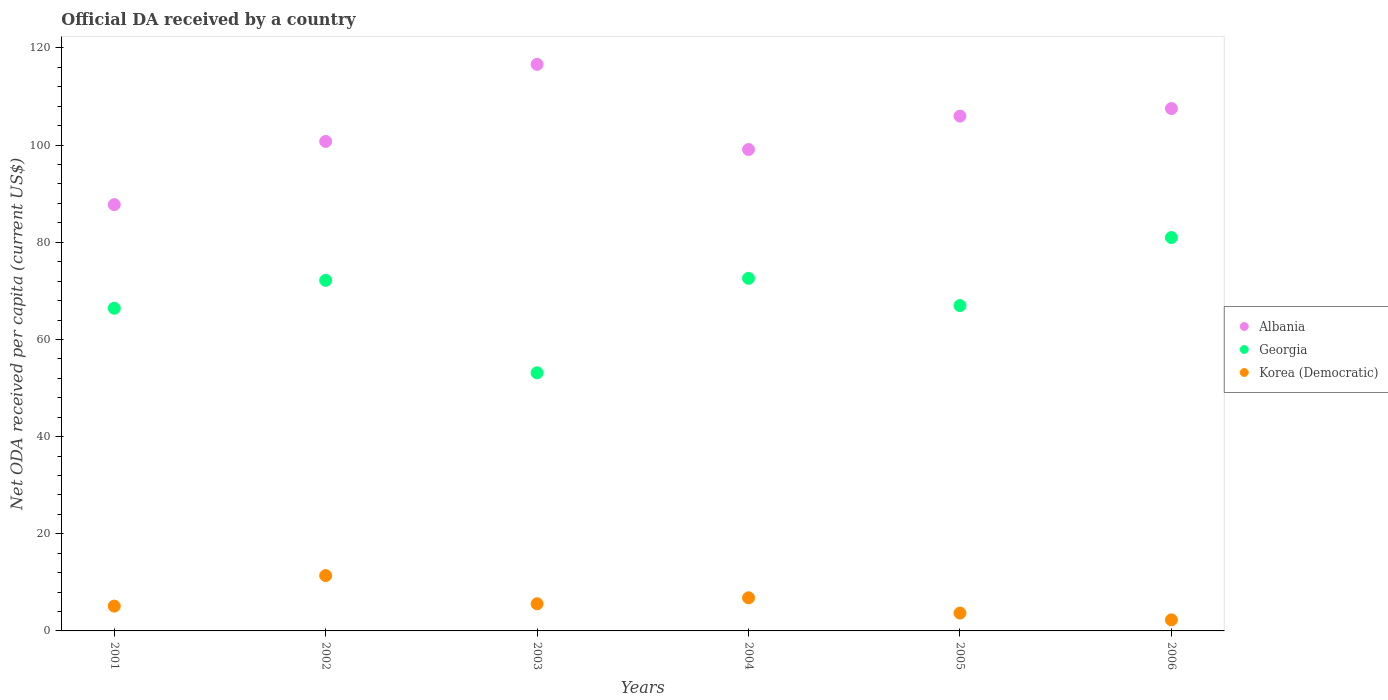What is the ODA received in in Georgia in 2005?
Offer a terse response. 66.97. Across all years, what is the maximum ODA received in in Georgia?
Your response must be concise. 80.98. Across all years, what is the minimum ODA received in in Korea (Democratic)?
Give a very brief answer. 2.28. In which year was the ODA received in in Albania maximum?
Keep it short and to the point. 2003. In which year was the ODA received in in Albania minimum?
Give a very brief answer. 2001. What is the total ODA received in in Korea (Democratic) in the graph?
Offer a very short reply. 34.85. What is the difference between the ODA received in in Albania in 2002 and that in 2005?
Offer a terse response. -5.21. What is the difference between the ODA received in in Georgia in 2002 and the ODA received in in Korea (Democratic) in 2003?
Ensure brevity in your answer.  66.58. What is the average ODA received in in Korea (Democratic) per year?
Provide a short and direct response. 5.81. In the year 2005, what is the difference between the ODA received in in Korea (Democratic) and ODA received in in Georgia?
Make the answer very short. -63.29. In how many years, is the ODA received in in Georgia greater than 68 US$?
Offer a very short reply. 3. What is the ratio of the ODA received in in Albania in 2002 to that in 2006?
Your response must be concise. 0.94. Is the difference between the ODA received in in Korea (Democratic) in 2004 and 2005 greater than the difference between the ODA received in in Georgia in 2004 and 2005?
Provide a succinct answer. No. What is the difference between the highest and the second highest ODA received in in Korea (Democratic)?
Provide a short and direct response. 4.57. What is the difference between the highest and the lowest ODA received in in Albania?
Your answer should be very brief. 28.88. In how many years, is the ODA received in in Georgia greater than the average ODA received in in Georgia taken over all years?
Provide a succinct answer. 3. Is the sum of the ODA received in in Georgia in 2003 and 2004 greater than the maximum ODA received in in Albania across all years?
Keep it short and to the point. Yes. Is it the case that in every year, the sum of the ODA received in in Georgia and ODA received in in Albania  is greater than the ODA received in in Korea (Democratic)?
Make the answer very short. Yes. Is the ODA received in in Korea (Democratic) strictly greater than the ODA received in in Albania over the years?
Your response must be concise. No. Is the ODA received in in Korea (Democratic) strictly less than the ODA received in in Georgia over the years?
Provide a short and direct response. Yes. How many dotlines are there?
Give a very brief answer. 3. What is the difference between two consecutive major ticks on the Y-axis?
Make the answer very short. 20. Are the values on the major ticks of Y-axis written in scientific E-notation?
Give a very brief answer. No. How many legend labels are there?
Ensure brevity in your answer.  3. What is the title of the graph?
Provide a succinct answer. Official DA received by a country. Does "Virgin Islands" appear as one of the legend labels in the graph?
Offer a terse response. No. What is the label or title of the Y-axis?
Offer a terse response. Net ODA received per capita (current US$). What is the Net ODA received per capita (current US$) of Albania in 2001?
Your answer should be very brief. 87.75. What is the Net ODA received per capita (current US$) in Georgia in 2001?
Ensure brevity in your answer.  66.42. What is the Net ODA received per capita (current US$) of Korea (Democratic) in 2001?
Offer a terse response. 5.11. What is the Net ODA received per capita (current US$) in Albania in 2002?
Provide a succinct answer. 100.76. What is the Net ODA received per capita (current US$) in Georgia in 2002?
Make the answer very short. 72.17. What is the Net ODA received per capita (current US$) of Korea (Democratic) in 2002?
Keep it short and to the point. 11.39. What is the Net ODA received per capita (current US$) in Albania in 2003?
Your answer should be very brief. 116.63. What is the Net ODA received per capita (current US$) in Georgia in 2003?
Give a very brief answer. 53.13. What is the Net ODA received per capita (current US$) in Korea (Democratic) in 2003?
Provide a succinct answer. 5.59. What is the Net ODA received per capita (current US$) in Albania in 2004?
Your response must be concise. 99.09. What is the Net ODA received per capita (current US$) in Georgia in 2004?
Make the answer very short. 72.58. What is the Net ODA received per capita (current US$) in Korea (Democratic) in 2004?
Offer a very short reply. 6.82. What is the Net ODA received per capita (current US$) in Albania in 2005?
Give a very brief answer. 105.97. What is the Net ODA received per capita (current US$) in Georgia in 2005?
Give a very brief answer. 66.97. What is the Net ODA received per capita (current US$) in Korea (Democratic) in 2005?
Give a very brief answer. 3.68. What is the Net ODA received per capita (current US$) in Albania in 2006?
Your answer should be compact. 107.53. What is the Net ODA received per capita (current US$) in Georgia in 2006?
Your response must be concise. 80.98. What is the Net ODA received per capita (current US$) in Korea (Democratic) in 2006?
Keep it short and to the point. 2.28. Across all years, what is the maximum Net ODA received per capita (current US$) in Albania?
Give a very brief answer. 116.63. Across all years, what is the maximum Net ODA received per capita (current US$) in Georgia?
Your answer should be very brief. 80.98. Across all years, what is the maximum Net ODA received per capita (current US$) in Korea (Democratic)?
Your answer should be compact. 11.39. Across all years, what is the minimum Net ODA received per capita (current US$) in Albania?
Your response must be concise. 87.75. Across all years, what is the minimum Net ODA received per capita (current US$) of Georgia?
Offer a terse response. 53.13. Across all years, what is the minimum Net ODA received per capita (current US$) in Korea (Democratic)?
Keep it short and to the point. 2.28. What is the total Net ODA received per capita (current US$) in Albania in the graph?
Provide a short and direct response. 617.73. What is the total Net ODA received per capita (current US$) of Georgia in the graph?
Provide a short and direct response. 412.25. What is the total Net ODA received per capita (current US$) of Korea (Democratic) in the graph?
Your answer should be very brief. 34.85. What is the difference between the Net ODA received per capita (current US$) in Albania in 2001 and that in 2002?
Your answer should be very brief. -13.01. What is the difference between the Net ODA received per capita (current US$) in Georgia in 2001 and that in 2002?
Your answer should be very brief. -5.75. What is the difference between the Net ODA received per capita (current US$) in Korea (Democratic) in 2001 and that in 2002?
Your response must be concise. -6.28. What is the difference between the Net ODA received per capita (current US$) in Albania in 2001 and that in 2003?
Provide a succinct answer. -28.88. What is the difference between the Net ODA received per capita (current US$) of Georgia in 2001 and that in 2003?
Offer a very short reply. 13.29. What is the difference between the Net ODA received per capita (current US$) in Korea (Democratic) in 2001 and that in 2003?
Provide a short and direct response. -0.48. What is the difference between the Net ODA received per capita (current US$) of Albania in 2001 and that in 2004?
Keep it short and to the point. -11.34. What is the difference between the Net ODA received per capita (current US$) in Georgia in 2001 and that in 2004?
Make the answer very short. -6.16. What is the difference between the Net ODA received per capita (current US$) of Korea (Democratic) in 2001 and that in 2004?
Offer a very short reply. -1.71. What is the difference between the Net ODA received per capita (current US$) of Albania in 2001 and that in 2005?
Offer a very short reply. -18.22. What is the difference between the Net ODA received per capita (current US$) in Georgia in 2001 and that in 2005?
Keep it short and to the point. -0.55. What is the difference between the Net ODA received per capita (current US$) of Korea (Democratic) in 2001 and that in 2005?
Your response must be concise. 1.43. What is the difference between the Net ODA received per capita (current US$) of Albania in 2001 and that in 2006?
Provide a short and direct response. -19.78. What is the difference between the Net ODA received per capita (current US$) in Georgia in 2001 and that in 2006?
Keep it short and to the point. -14.56. What is the difference between the Net ODA received per capita (current US$) in Korea (Democratic) in 2001 and that in 2006?
Make the answer very short. 2.83. What is the difference between the Net ODA received per capita (current US$) of Albania in 2002 and that in 2003?
Offer a very short reply. -15.87. What is the difference between the Net ODA received per capita (current US$) of Georgia in 2002 and that in 2003?
Ensure brevity in your answer.  19.04. What is the difference between the Net ODA received per capita (current US$) in Korea (Democratic) in 2002 and that in 2003?
Keep it short and to the point. 5.8. What is the difference between the Net ODA received per capita (current US$) in Albania in 2002 and that in 2004?
Provide a succinct answer. 1.67. What is the difference between the Net ODA received per capita (current US$) of Georgia in 2002 and that in 2004?
Provide a succinct answer. -0.41. What is the difference between the Net ODA received per capita (current US$) of Korea (Democratic) in 2002 and that in 2004?
Provide a succinct answer. 4.57. What is the difference between the Net ODA received per capita (current US$) of Albania in 2002 and that in 2005?
Provide a succinct answer. -5.21. What is the difference between the Net ODA received per capita (current US$) of Georgia in 2002 and that in 2005?
Keep it short and to the point. 5.2. What is the difference between the Net ODA received per capita (current US$) in Korea (Democratic) in 2002 and that in 2005?
Provide a short and direct response. 7.71. What is the difference between the Net ODA received per capita (current US$) of Albania in 2002 and that in 2006?
Provide a short and direct response. -6.77. What is the difference between the Net ODA received per capita (current US$) in Georgia in 2002 and that in 2006?
Your answer should be compact. -8.81. What is the difference between the Net ODA received per capita (current US$) of Korea (Democratic) in 2002 and that in 2006?
Provide a short and direct response. 9.11. What is the difference between the Net ODA received per capita (current US$) of Albania in 2003 and that in 2004?
Offer a terse response. 17.53. What is the difference between the Net ODA received per capita (current US$) in Georgia in 2003 and that in 2004?
Provide a short and direct response. -19.45. What is the difference between the Net ODA received per capita (current US$) of Korea (Democratic) in 2003 and that in 2004?
Your response must be concise. -1.23. What is the difference between the Net ODA received per capita (current US$) of Albania in 2003 and that in 2005?
Ensure brevity in your answer.  10.65. What is the difference between the Net ODA received per capita (current US$) of Georgia in 2003 and that in 2005?
Keep it short and to the point. -13.84. What is the difference between the Net ODA received per capita (current US$) of Korea (Democratic) in 2003 and that in 2005?
Keep it short and to the point. 1.91. What is the difference between the Net ODA received per capita (current US$) in Albania in 2003 and that in 2006?
Ensure brevity in your answer.  9.1. What is the difference between the Net ODA received per capita (current US$) in Georgia in 2003 and that in 2006?
Ensure brevity in your answer.  -27.84. What is the difference between the Net ODA received per capita (current US$) in Korea (Democratic) in 2003 and that in 2006?
Offer a very short reply. 3.31. What is the difference between the Net ODA received per capita (current US$) of Albania in 2004 and that in 2005?
Ensure brevity in your answer.  -6.88. What is the difference between the Net ODA received per capita (current US$) of Georgia in 2004 and that in 2005?
Offer a terse response. 5.61. What is the difference between the Net ODA received per capita (current US$) in Korea (Democratic) in 2004 and that in 2005?
Provide a short and direct response. 3.14. What is the difference between the Net ODA received per capita (current US$) in Albania in 2004 and that in 2006?
Your response must be concise. -8.43. What is the difference between the Net ODA received per capita (current US$) of Georgia in 2004 and that in 2006?
Your answer should be very brief. -8.4. What is the difference between the Net ODA received per capita (current US$) of Korea (Democratic) in 2004 and that in 2006?
Ensure brevity in your answer.  4.54. What is the difference between the Net ODA received per capita (current US$) of Albania in 2005 and that in 2006?
Offer a terse response. -1.55. What is the difference between the Net ODA received per capita (current US$) in Georgia in 2005 and that in 2006?
Provide a short and direct response. -14.01. What is the difference between the Net ODA received per capita (current US$) in Korea (Democratic) in 2005 and that in 2006?
Offer a terse response. 1.4. What is the difference between the Net ODA received per capita (current US$) in Albania in 2001 and the Net ODA received per capita (current US$) in Georgia in 2002?
Make the answer very short. 15.58. What is the difference between the Net ODA received per capita (current US$) of Albania in 2001 and the Net ODA received per capita (current US$) of Korea (Democratic) in 2002?
Provide a short and direct response. 76.36. What is the difference between the Net ODA received per capita (current US$) in Georgia in 2001 and the Net ODA received per capita (current US$) in Korea (Democratic) in 2002?
Your answer should be compact. 55.03. What is the difference between the Net ODA received per capita (current US$) in Albania in 2001 and the Net ODA received per capita (current US$) in Georgia in 2003?
Your answer should be compact. 34.62. What is the difference between the Net ODA received per capita (current US$) of Albania in 2001 and the Net ODA received per capita (current US$) of Korea (Democratic) in 2003?
Your answer should be very brief. 82.16. What is the difference between the Net ODA received per capita (current US$) of Georgia in 2001 and the Net ODA received per capita (current US$) of Korea (Democratic) in 2003?
Offer a very short reply. 60.84. What is the difference between the Net ODA received per capita (current US$) of Albania in 2001 and the Net ODA received per capita (current US$) of Georgia in 2004?
Make the answer very short. 15.17. What is the difference between the Net ODA received per capita (current US$) in Albania in 2001 and the Net ODA received per capita (current US$) in Korea (Democratic) in 2004?
Keep it short and to the point. 80.93. What is the difference between the Net ODA received per capita (current US$) of Georgia in 2001 and the Net ODA received per capita (current US$) of Korea (Democratic) in 2004?
Provide a succinct answer. 59.6. What is the difference between the Net ODA received per capita (current US$) in Albania in 2001 and the Net ODA received per capita (current US$) in Georgia in 2005?
Offer a very short reply. 20.78. What is the difference between the Net ODA received per capita (current US$) in Albania in 2001 and the Net ODA received per capita (current US$) in Korea (Democratic) in 2005?
Ensure brevity in your answer.  84.07. What is the difference between the Net ODA received per capita (current US$) in Georgia in 2001 and the Net ODA received per capita (current US$) in Korea (Democratic) in 2005?
Provide a succinct answer. 62.74. What is the difference between the Net ODA received per capita (current US$) in Albania in 2001 and the Net ODA received per capita (current US$) in Georgia in 2006?
Keep it short and to the point. 6.77. What is the difference between the Net ODA received per capita (current US$) in Albania in 2001 and the Net ODA received per capita (current US$) in Korea (Democratic) in 2006?
Your answer should be very brief. 85.47. What is the difference between the Net ODA received per capita (current US$) of Georgia in 2001 and the Net ODA received per capita (current US$) of Korea (Democratic) in 2006?
Give a very brief answer. 64.14. What is the difference between the Net ODA received per capita (current US$) in Albania in 2002 and the Net ODA received per capita (current US$) in Georgia in 2003?
Your answer should be compact. 47.63. What is the difference between the Net ODA received per capita (current US$) in Albania in 2002 and the Net ODA received per capita (current US$) in Korea (Democratic) in 2003?
Your response must be concise. 95.17. What is the difference between the Net ODA received per capita (current US$) in Georgia in 2002 and the Net ODA received per capita (current US$) in Korea (Democratic) in 2003?
Offer a very short reply. 66.58. What is the difference between the Net ODA received per capita (current US$) of Albania in 2002 and the Net ODA received per capita (current US$) of Georgia in 2004?
Make the answer very short. 28.18. What is the difference between the Net ODA received per capita (current US$) in Albania in 2002 and the Net ODA received per capita (current US$) in Korea (Democratic) in 2004?
Provide a succinct answer. 93.94. What is the difference between the Net ODA received per capita (current US$) of Georgia in 2002 and the Net ODA received per capita (current US$) of Korea (Democratic) in 2004?
Keep it short and to the point. 65.35. What is the difference between the Net ODA received per capita (current US$) in Albania in 2002 and the Net ODA received per capita (current US$) in Georgia in 2005?
Your answer should be compact. 33.79. What is the difference between the Net ODA received per capita (current US$) in Albania in 2002 and the Net ODA received per capita (current US$) in Korea (Democratic) in 2005?
Your response must be concise. 97.08. What is the difference between the Net ODA received per capita (current US$) of Georgia in 2002 and the Net ODA received per capita (current US$) of Korea (Democratic) in 2005?
Offer a terse response. 68.49. What is the difference between the Net ODA received per capita (current US$) of Albania in 2002 and the Net ODA received per capita (current US$) of Georgia in 2006?
Provide a succinct answer. 19.78. What is the difference between the Net ODA received per capita (current US$) in Albania in 2002 and the Net ODA received per capita (current US$) in Korea (Democratic) in 2006?
Provide a short and direct response. 98.48. What is the difference between the Net ODA received per capita (current US$) in Georgia in 2002 and the Net ODA received per capita (current US$) in Korea (Democratic) in 2006?
Make the answer very short. 69.89. What is the difference between the Net ODA received per capita (current US$) of Albania in 2003 and the Net ODA received per capita (current US$) of Georgia in 2004?
Provide a short and direct response. 44.05. What is the difference between the Net ODA received per capita (current US$) of Albania in 2003 and the Net ODA received per capita (current US$) of Korea (Democratic) in 2004?
Your answer should be very brief. 109.81. What is the difference between the Net ODA received per capita (current US$) in Georgia in 2003 and the Net ODA received per capita (current US$) in Korea (Democratic) in 2004?
Provide a short and direct response. 46.32. What is the difference between the Net ODA received per capita (current US$) in Albania in 2003 and the Net ODA received per capita (current US$) in Georgia in 2005?
Provide a short and direct response. 49.66. What is the difference between the Net ODA received per capita (current US$) in Albania in 2003 and the Net ODA received per capita (current US$) in Korea (Democratic) in 2005?
Give a very brief answer. 112.95. What is the difference between the Net ODA received per capita (current US$) in Georgia in 2003 and the Net ODA received per capita (current US$) in Korea (Democratic) in 2005?
Provide a succinct answer. 49.46. What is the difference between the Net ODA received per capita (current US$) in Albania in 2003 and the Net ODA received per capita (current US$) in Georgia in 2006?
Your answer should be very brief. 35.65. What is the difference between the Net ODA received per capita (current US$) in Albania in 2003 and the Net ODA received per capita (current US$) in Korea (Democratic) in 2006?
Provide a short and direct response. 114.35. What is the difference between the Net ODA received per capita (current US$) of Georgia in 2003 and the Net ODA received per capita (current US$) of Korea (Democratic) in 2006?
Give a very brief answer. 50.85. What is the difference between the Net ODA received per capita (current US$) of Albania in 2004 and the Net ODA received per capita (current US$) of Georgia in 2005?
Your answer should be compact. 32.12. What is the difference between the Net ODA received per capita (current US$) of Albania in 2004 and the Net ODA received per capita (current US$) of Korea (Democratic) in 2005?
Offer a very short reply. 95.42. What is the difference between the Net ODA received per capita (current US$) in Georgia in 2004 and the Net ODA received per capita (current US$) in Korea (Democratic) in 2005?
Your answer should be very brief. 68.9. What is the difference between the Net ODA received per capita (current US$) in Albania in 2004 and the Net ODA received per capita (current US$) in Georgia in 2006?
Offer a terse response. 18.12. What is the difference between the Net ODA received per capita (current US$) in Albania in 2004 and the Net ODA received per capita (current US$) in Korea (Democratic) in 2006?
Your answer should be compact. 96.81. What is the difference between the Net ODA received per capita (current US$) in Georgia in 2004 and the Net ODA received per capita (current US$) in Korea (Democratic) in 2006?
Your answer should be compact. 70.3. What is the difference between the Net ODA received per capita (current US$) of Albania in 2005 and the Net ODA received per capita (current US$) of Georgia in 2006?
Offer a terse response. 25. What is the difference between the Net ODA received per capita (current US$) in Albania in 2005 and the Net ODA received per capita (current US$) in Korea (Democratic) in 2006?
Your answer should be very brief. 103.69. What is the difference between the Net ODA received per capita (current US$) of Georgia in 2005 and the Net ODA received per capita (current US$) of Korea (Democratic) in 2006?
Make the answer very short. 64.69. What is the average Net ODA received per capita (current US$) of Albania per year?
Provide a succinct answer. 102.96. What is the average Net ODA received per capita (current US$) of Georgia per year?
Offer a very short reply. 68.71. What is the average Net ODA received per capita (current US$) of Korea (Democratic) per year?
Provide a succinct answer. 5.81. In the year 2001, what is the difference between the Net ODA received per capita (current US$) in Albania and Net ODA received per capita (current US$) in Georgia?
Ensure brevity in your answer.  21.33. In the year 2001, what is the difference between the Net ODA received per capita (current US$) of Albania and Net ODA received per capita (current US$) of Korea (Democratic)?
Your answer should be compact. 82.64. In the year 2001, what is the difference between the Net ODA received per capita (current US$) in Georgia and Net ODA received per capita (current US$) in Korea (Democratic)?
Your answer should be very brief. 61.32. In the year 2002, what is the difference between the Net ODA received per capita (current US$) of Albania and Net ODA received per capita (current US$) of Georgia?
Your answer should be very brief. 28.59. In the year 2002, what is the difference between the Net ODA received per capita (current US$) of Albania and Net ODA received per capita (current US$) of Korea (Democratic)?
Give a very brief answer. 89.37. In the year 2002, what is the difference between the Net ODA received per capita (current US$) of Georgia and Net ODA received per capita (current US$) of Korea (Democratic)?
Provide a succinct answer. 60.78. In the year 2003, what is the difference between the Net ODA received per capita (current US$) of Albania and Net ODA received per capita (current US$) of Georgia?
Your answer should be compact. 63.49. In the year 2003, what is the difference between the Net ODA received per capita (current US$) in Albania and Net ODA received per capita (current US$) in Korea (Democratic)?
Your response must be concise. 111.04. In the year 2003, what is the difference between the Net ODA received per capita (current US$) of Georgia and Net ODA received per capita (current US$) of Korea (Democratic)?
Provide a succinct answer. 47.55. In the year 2004, what is the difference between the Net ODA received per capita (current US$) in Albania and Net ODA received per capita (current US$) in Georgia?
Your response must be concise. 26.51. In the year 2004, what is the difference between the Net ODA received per capita (current US$) of Albania and Net ODA received per capita (current US$) of Korea (Democratic)?
Ensure brevity in your answer.  92.28. In the year 2004, what is the difference between the Net ODA received per capita (current US$) of Georgia and Net ODA received per capita (current US$) of Korea (Democratic)?
Ensure brevity in your answer.  65.76. In the year 2005, what is the difference between the Net ODA received per capita (current US$) of Albania and Net ODA received per capita (current US$) of Georgia?
Give a very brief answer. 39. In the year 2005, what is the difference between the Net ODA received per capita (current US$) of Albania and Net ODA received per capita (current US$) of Korea (Democratic)?
Offer a very short reply. 102.3. In the year 2005, what is the difference between the Net ODA received per capita (current US$) of Georgia and Net ODA received per capita (current US$) of Korea (Democratic)?
Your response must be concise. 63.29. In the year 2006, what is the difference between the Net ODA received per capita (current US$) in Albania and Net ODA received per capita (current US$) in Georgia?
Provide a succinct answer. 26.55. In the year 2006, what is the difference between the Net ODA received per capita (current US$) of Albania and Net ODA received per capita (current US$) of Korea (Democratic)?
Provide a succinct answer. 105.25. In the year 2006, what is the difference between the Net ODA received per capita (current US$) of Georgia and Net ODA received per capita (current US$) of Korea (Democratic)?
Make the answer very short. 78.7. What is the ratio of the Net ODA received per capita (current US$) in Albania in 2001 to that in 2002?
Ensure brevity in your answer.  0.87. What is the ratio of the Net ODA received per capita (current US$) in Georgia in 2001 to that in 2002?
Your response must be concise. 0.92. What is the ratio of the Net ODA received per capita (current US$) of Korea (Democratic) in 2001 to that in 2002?
Ensure brevity in your answer.  0.45. What is the ratio of the Net ODA received per capita (current US$) of Albania in 2001 to that in 2003?
Offer a terse response. 0.75. What is the ratio of the Net ODA received per capita (current US$) in Georgia in 2001 to that in 2003?
Offer a terse response. 1.25. What is the ratio of the Net ODA received per capita (current US$) in Korea (Democratic) in 2001 to that in 2003?
Provide a succinct answer. 0.91. What is the ratio of the Net ODA received per capita (current US$) in Albania in 2001 to that in 2004?
Provide a succinct answer. 0.89. What is the ratio of the Net ODA received per capita (current US$) in Georgia in 2001 to that in 2004?
Give a very brief answer. 0.92. What is the ratio of the Net ODA received per capita (current US$) of Korea (Democratic) in 2001 to that in 2004?
Make the answer very short. 0.75. What is the ratio of the Net ODA received per capita (current US$) in Albania in 2001 to that in 2005?
Keep it short and to the point. 0.83. What is the ratio of the Net ODA received per capita (current US$) in Georgia in 2001 to that in 2005?
Keep it short and to the point. 0.99. What is the ratio of the Net ODA received per capita (current US$) of Korea (Democratic) in 2001 to that in 2005?
Your response must be concise. 1.39. What is the ratio of the Net ODA received per capita (current US$) in Albania in 2001 to that in 2006?
Offer a terse response. 0.82. What is the ratio of the Net ODA received per capita (current US$) in Georgia in 2001 to that in 2006?
Offer a terse response. 0.82. What is the ratio of the Net ODA received per capita (current US$) in Korea (Democratic) in 2001 to that in 2006?
Your answer should be compact. 2.24. What is the ratio of the Net ODA received per capita (current US$) of Albania in 2002 to that in 2003?
Keep it short and to the point. 0.86. What is the ratio of the Net ODA received per capita (current US$) in Georgia in 2002 to that in 2003?
Offer a very short reply. 1.36. What is the ratio of the Net ODA received per capita (current US$) of Korea (Democratic) in 2002 to that in 2003?
Give a very brief answer. 2.04. What is the ratio of the Net ODA received per capita (current US$) of Albania in 2002 to that in 2004?
Your response must be concise. 1.02. What is the ratio of the Net ODA received per capita (current US$) in Georgia in 2002 to that in 2004?
Your answer should be compact. 0.99. What is the ratio of the Net ODA received per capita (current US$) in Korea (Democratic) in 2002 to that in 2004?
Ensure brevity in your answer.  1.67. What is the ratio of the Net ODA received per capita (current US$) in Albania in 2002 to that in 2005?
Your answer should be compact. 0.95. What is the ratio of the Net ODA received per capita (current US$) of Georgia in 2002 to that in 2005?
Keep it short and to the point. 1.08. What is the ratio of the Net ODA received per capita (current US$) of Korea (Democratic) in 2002 to that in 2005?
Make the answer very short. 3.1. What is the ratio of the Net ODA received per capita (current US$) of Albania in 2002 to that in 2006?
Your answer should be compact. 0.94. What is the ratio of the Net ODA received per capita (current US$) in Georgia in 2002 to that in 2006?
Offer a very short reply. 0.89. What is the ratio of the Net ODA received per capita (current US$) of Korea (Democratic) in 2002 to that in 2006?
Your response must be concise. 5. What is the ratio of the Net ODA received per capita (current US$) of Albania in 2003 to that in 2004?
Offer a terse response. 1.18. What is the ratio of the Net ODA received per capita (current US$) of Georgia in 2003 to that in 2004?
Offer a very short reply. 0.73. What is the ratio of the Net ODA received per capita (current US$) of Korea (Democratic) in 2003 to that in 2004?
Your answer should be very brief. 0.82. What is the ratio of the Net ODA received per capita (current US$) of Albania in 2003 to that in 2005?
Your answer should be very brief. 1.1. What is the ratio of the Net ODA received per capita (current US$) of Georgia in 2003 to that in 2005?
Your answer should be very brief. 0.79. What is the ratio of the Net ODA received per capita (current US$) in Korea (Democratic) in 2003 to that in 2005?
Provide a succinct answer. 1.52. What is the ratio of the Net ODA received per capita (current US$) of Albania in 2003 to that in 2006?
Ensure brevity in your answer.  1.08. What is the ratio of the Net ODA received per capita (current US$) of Georgia in 2003 to that in 2006?
Keep it short and to the point. 0.66. What is the ratio of the Net ODA received per capita (current US$) of Korea (Democratic) in 2003 to that in 2006?
Provide a short and direct response. 2.45. What is the ratio of the Net ODA received per capita (current US$) of Albania in 2004 to that in 2005?
Offer a very short reply. 0.94. What is the ratio of the Net ODA received per capita (current US$) of Georgia in 2004 to that in 2005?
Provide a short and direct response. 1.08. What is the ratio of the Net ODA received per capita (current US$) of Korea (Democratic) in 2004 to that in 2005?
Provide a short and direct response. 1.85. What is the ratio of the Net ODA received per capita (current US$) in Albania in 2004 to that in 2006?
Ensure brevity in your answer.  0.92. What is the ratio of the Net ODA received per capita (current US$) in Georgia in 2004 to that in 2006?
Provide a succinct answer. 0.9. What is the ratio of the Net ODA received per capita (current US$) of Korea (Democratic) in 2004 to that in 2006?
Offer a very short reply. 2.99. What is the ratio of the Net ODA received per capita (current US$) in Albania in 2005 to that in 2006?
Your answer should be very brief. 0.99. What is the ratio of the Net ODA received per capita (current US$) in Georgia in 2005 to that in 2006?
Offer a terse response. 0.83. What is the ratio of the Net ODA received per capita (current US$) of Korea (Democratic) in 2005 to that in 2006?
Give a very brief answer. 1.61. What is the difference between the highest and the second highest Net ODA received per capita (current US$) of Albania?
Your response must be concise. 9.1. What is the difference between the highest and the second highest Net ODA received per capita (current US$) in Georgia?
Provide a succinct answer. 8.4. What is the difference between the highest and the second highest Net ODA received per capita (current US$) in Korea (Democratic)?
Your answer should be very brief. 4.57. What is the difference between the highest and the lowest Net ODA received per capita (current US$) in Albania?
Offer a very short reply. 28.88. What is the difference between the highest and the lowest Net ODA received per capita (current US$) in Georgia?
Give a very brief answer. 27.84. What is the difference between the highest and the lowest Net ODA received per capita (current US$) in Korea (Democratic)?
Offer a terse response. 9.11. 